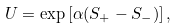<formula> <loc_0><loc_0><loc_500><loc_500>U = \exp \left [ \alpha ( S _ { + } - S _ { - } ) \right ] ,</formula> 